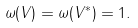<formula> <loc_0><loc_0><loc_500><loc_500>\omega ( V ) = \omega ( V ^ { * } ) = 1 .</formula> 